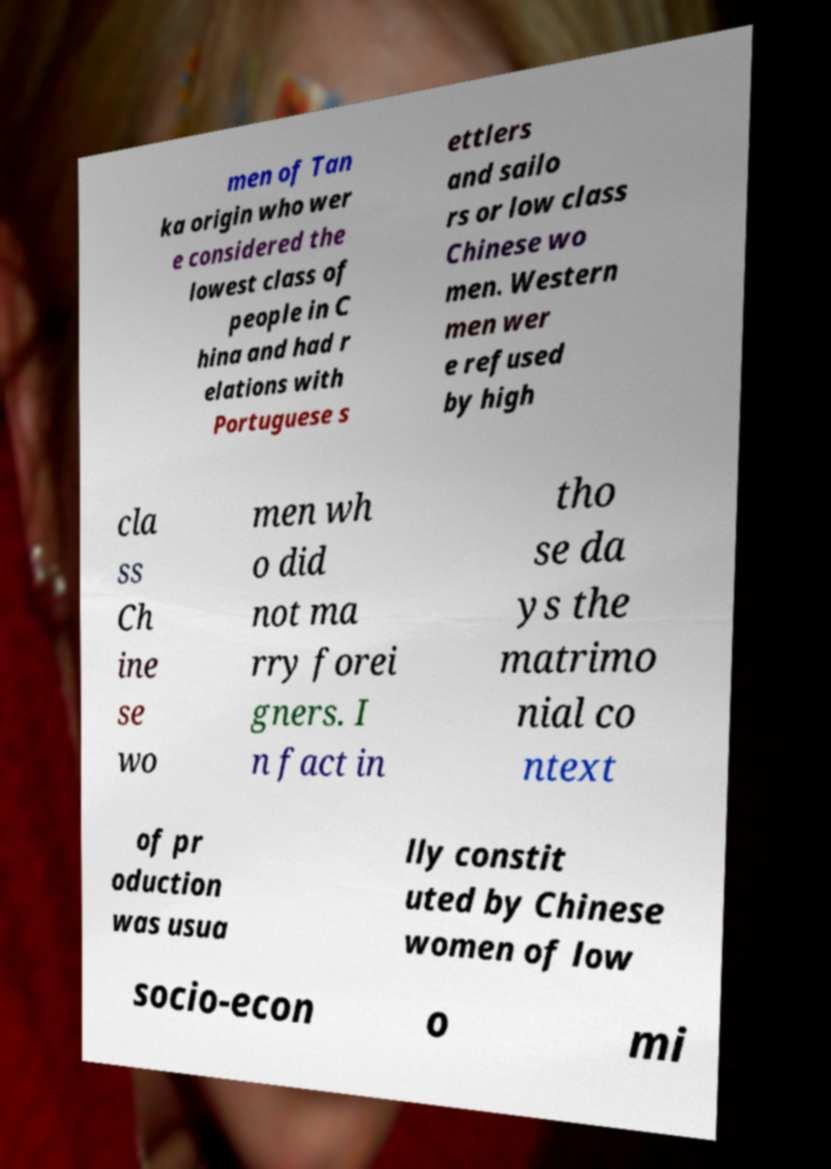Could you assist in decoding the text presented in this image and type it out clearly? men of Tan ka origin who wer e considered the lowest class of people in C hina and had r elations with Portuguese s ettlers and sailo rs or low class Chinese wo men. Western men wer e refused by high cla ss Ch ine se wo men wh o did not ma rry forei gners. I n fact in tho se da ys the matrimo nial co ntext of pr oduction was usua lly constit uted by Chinese women of low socio-econ o mi 